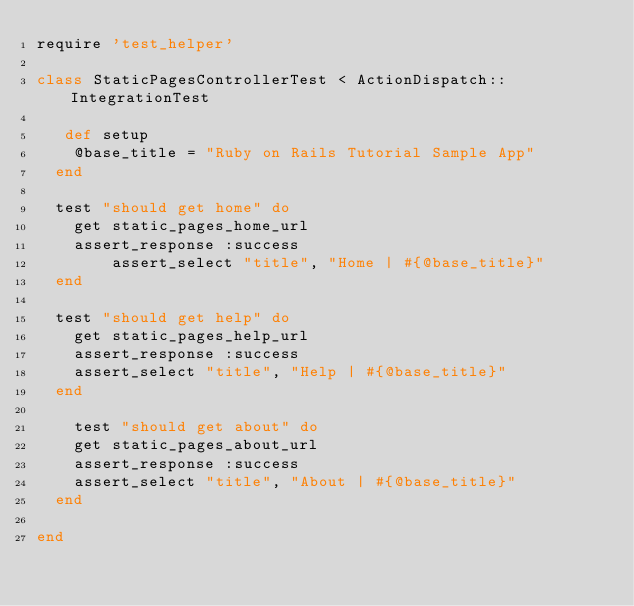<code> <loc_0><loc_0><loc_500><loc_500><_Ruby_>require 'test_helper'

class StaticPagesControllerTest < ActionDispatch::IntegrationTest
  
   def setup
    @base_title = "Ruby on Rails Tutorial Sample App"
  end

  test "should get home" do
    get static_pages_home_url
    assert_response :success
        assert_select "title", "Home | #{@base_title}"
  end

  test "should get help" do
    get static_pages_help_url
    assert_response :success
    assert_select "title", "Help | #{@base_title}"
  end
  
    test "should get about" do
    get static_pages_about_url
    assert_response :success
    assert_select "title", "About | #{@base_title}"
  end

end
</code> 